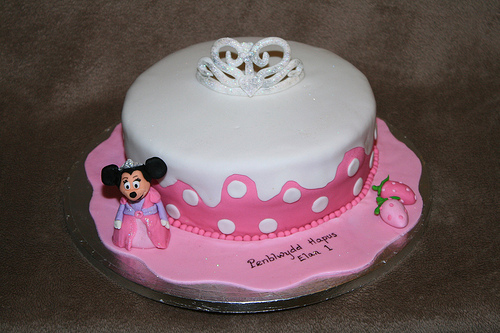<image>
Can you confirm if the minnie mouse is on the cake? Yes. Looking at the image, I can see the minnie mouse is positioned on top of the cake, with the cake providing support. Is there a plate under the cake? Yes. The plate is positioned underneath the cake, with the cake above it in the vertical space. 